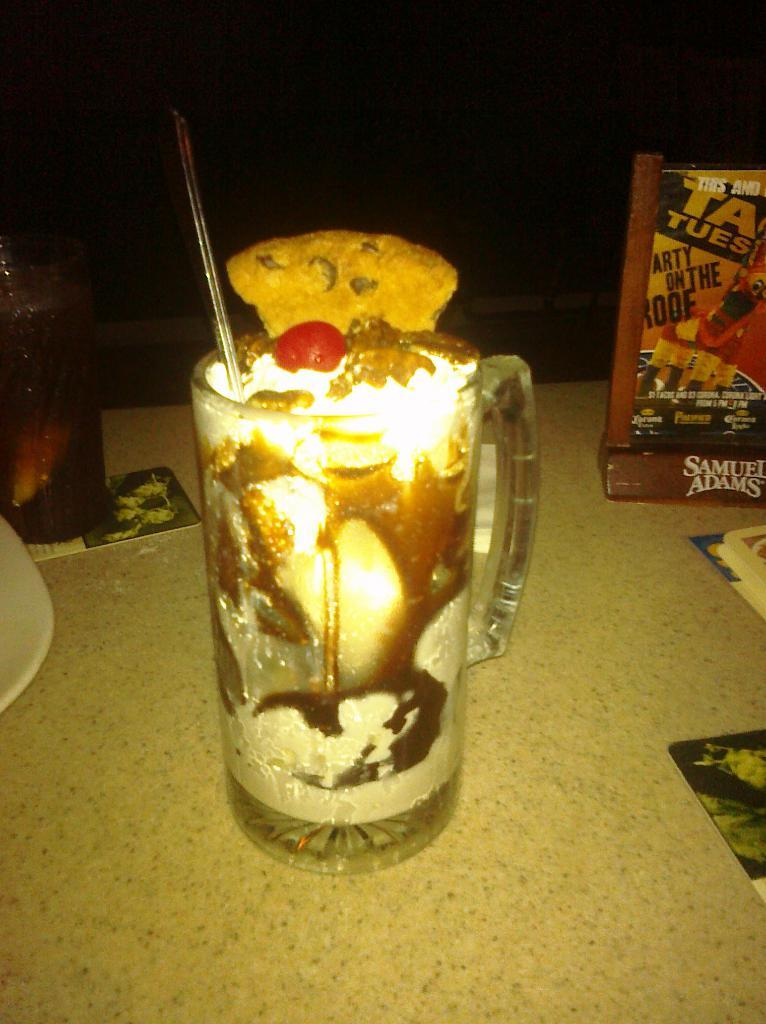<image>
Create a compact narrative representing the image presented. A glass containing a drink ready to serve to the ight of which is a box containing the letters TA TUES. 